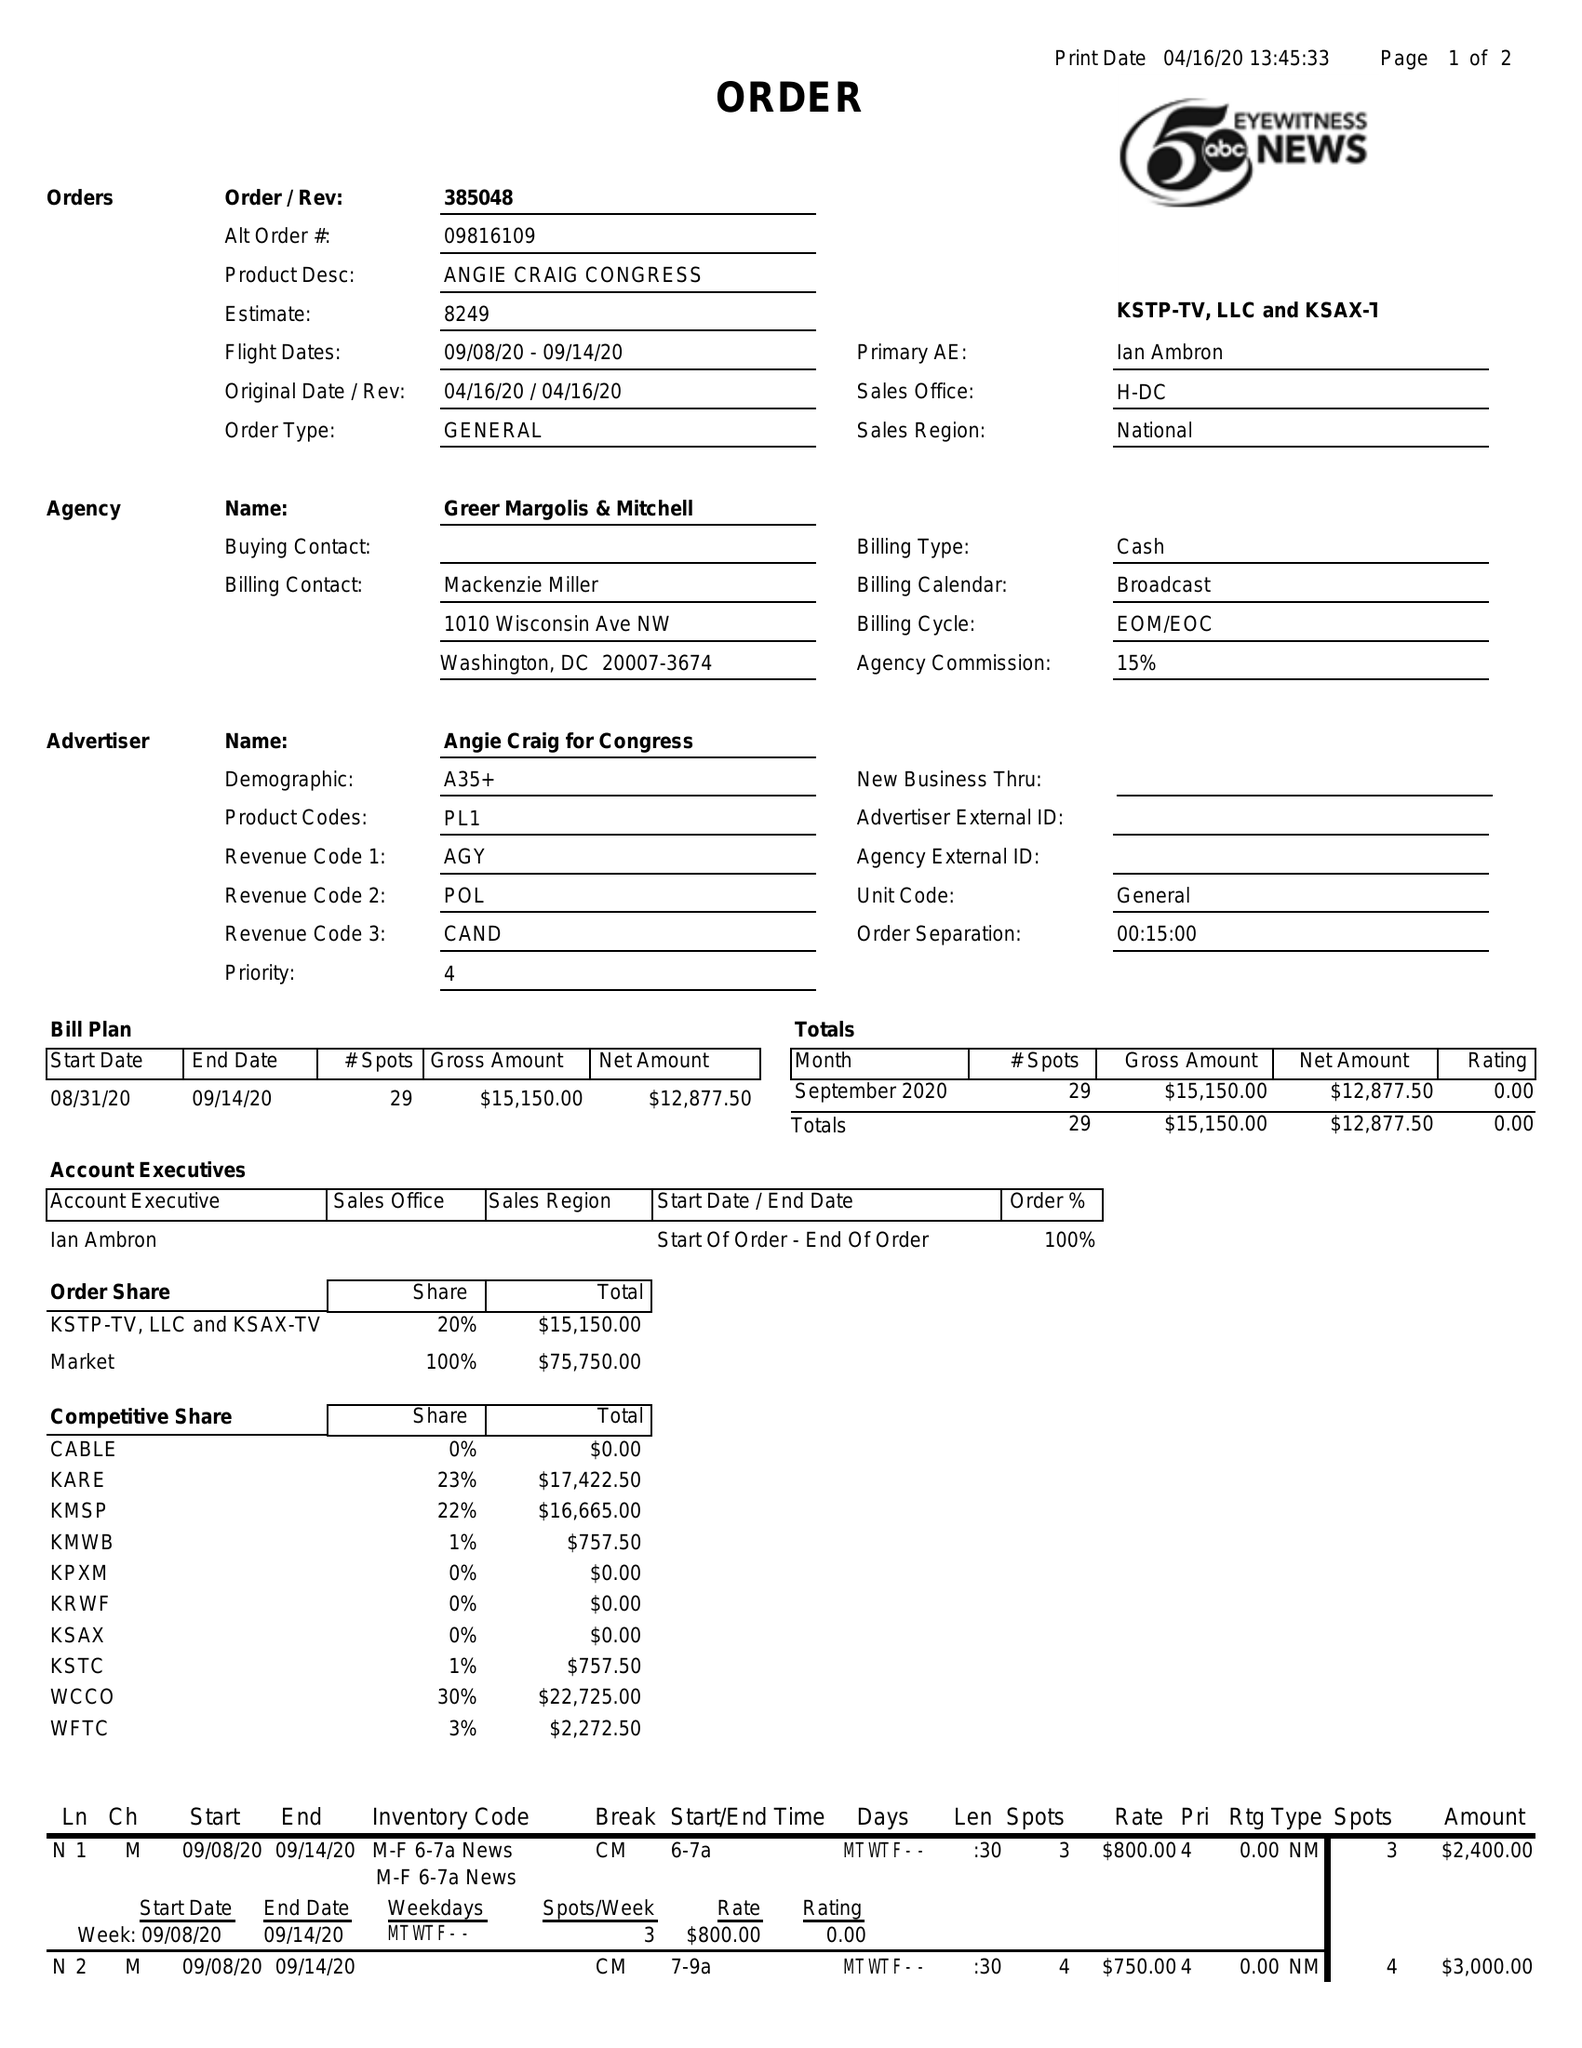What is the value for the contract_num?
Answer the question using a single word or phrase. 385048 